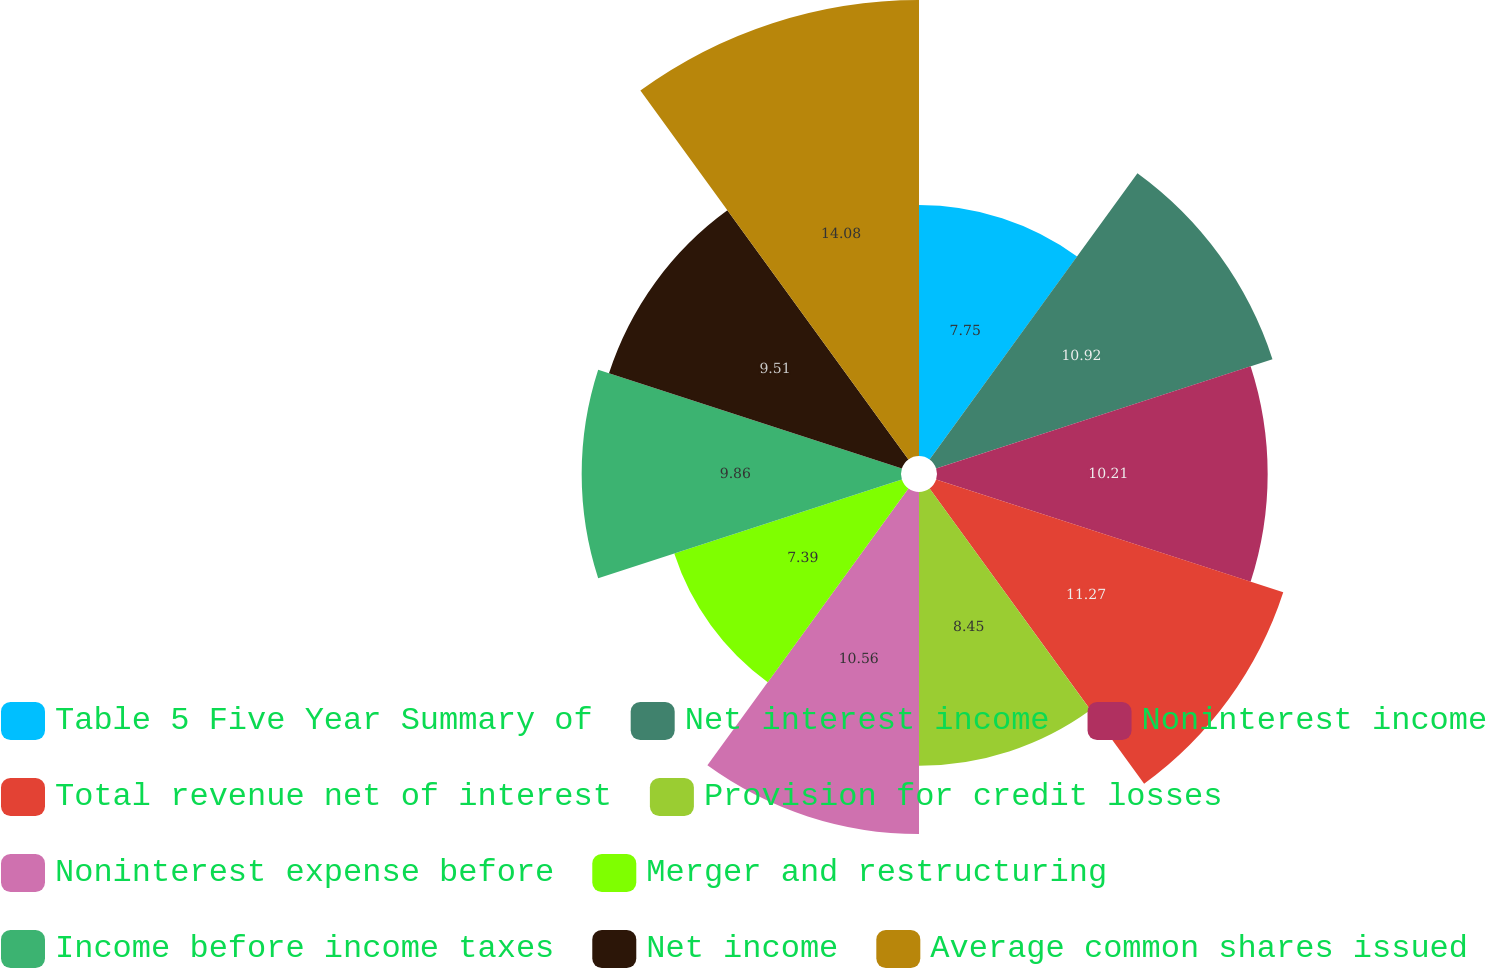<chart> <loc_0><loc_0><loc_500><loc_500><pie_chart><fcel>Table 5 Five Year Summary of<fcel>Net interest income<fcel>Noninterest income<fcel>Total revenue net of interest<fcel>Provision for credit losses<fcel>Noninterest expense before<fcel>Merger and restructuring<fcel>Income before income taxes<fcel>Net income<fcel>Average common shares issued<nl><fcel>7.75%<fcel>10.92%<fcel>10.21%<fcel>11.27%<fcel>8.45%<fcel>10.56%<fcel>7.39%<fcel>9.86%<fcel>9.51%<fcel>14.08%<nl></chart> 